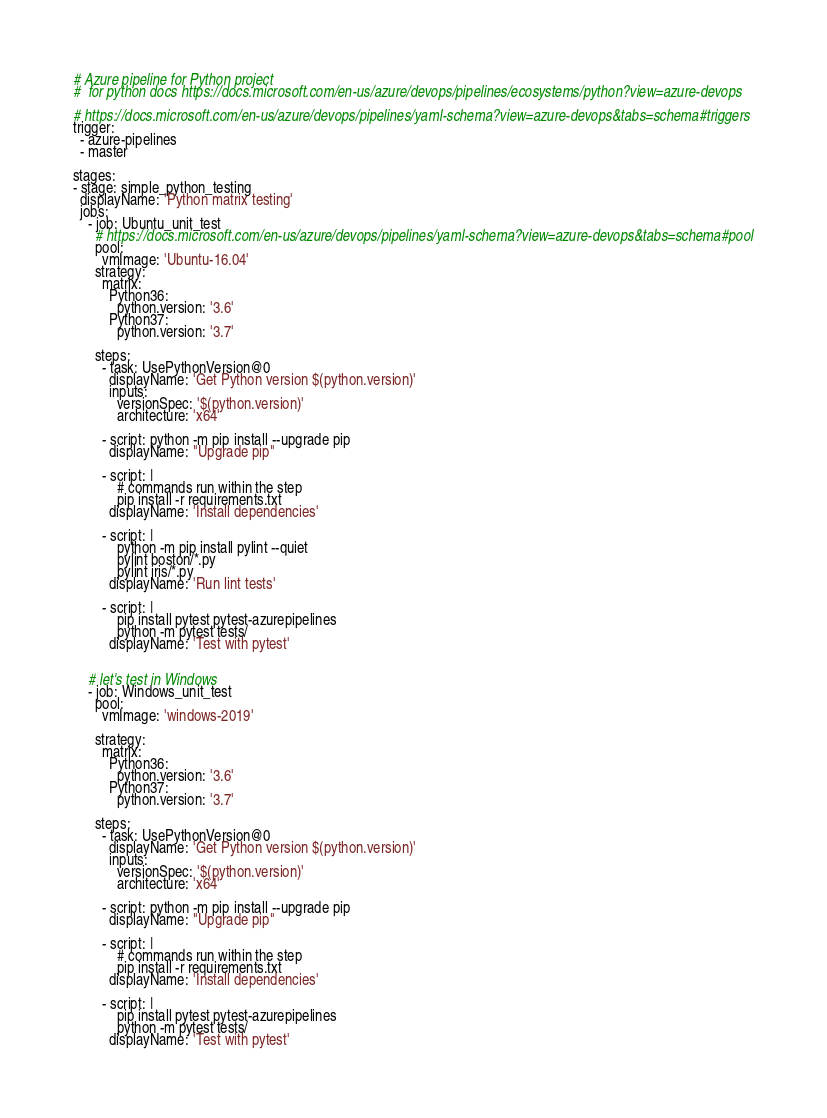Convert code to text. <code><loc_0><loc_0><loc_500><loc_500><_YAML_># Azure pipeline for Python project
#  for python docs https://docs.microsoft.com/en-us/azure/devops/pipelines/ecosystems/python?view=azure-devops

# https://docs.microsoft.com/en-us/azure/devops/pipelines/yaml-schema?view=azure-devops&tabs=schema#triggers
trigger:
  - azure-pipelines
  - master 

stages:
- stage: simple_python_testing
  displayName: 'Python matrix testing'
  jobs:
    - job: Ubuntu_unit_test
      # https://docs.microsoft.com/en-us/azure/devops/pipelines/yaml-schema?view=azure-devops&tabs=schema#pool
      pool:
        vmImage: 'Ubuntu-16.04'
      strategy:
        matrix:
          Python36:
            python.version: '3.6'
          Python37:
            python.version: '3.7'

      steps:
        - task: UsePythonVersion@0
          displayName: 'Get Python version $(python.version)' 
          inputs:
            versionSpec: '$(python.version)'
            architecture: 'x64'
          
        - script: python -m pip install --upgrade pip
          displayName: "Upgrade pip"

        - script: |
            # commands run within the step
            pip install -r requirements.txt
          displayName: 'Install dependencies'

        - script: |
            python -m pip install pylint --quiet
            pylint boston/*.py
            pylint iris/*.py
          displayName: 'Run lint tests'

        - script: |
            pip install pytest pytest-azurepipelines
            python -m pytest tests/
          displayName: 'Test with pytest'
                
    
    # let's test in Windows
    - job: Windows_unit_test
      pool:
        vmImage: 'windows-2019'

      strategy:
        matrix:
          Python36:
            python.version: '3.6'
          Python37:
            python.version: '3.7'

      steps:
        - task: UsePythonVersion@0
          displayName: 'Get Python version $(python.version)' 
          inputs:
            versionSpec: '$(python.version)'
            architecture: 'x64'
          
        - script: python -m pip install --upgrade pip
          displayName: "Upgrade pip"

        - script: |
            # commands run within the step
            pip install -r requirements.txt
          displayName: 'Install dependencies'

        - script: |
            pip install pytest pytest-azurepipelines
            python -m pytest tests/ 
          displayName: 'Test with pytest'
</code> 